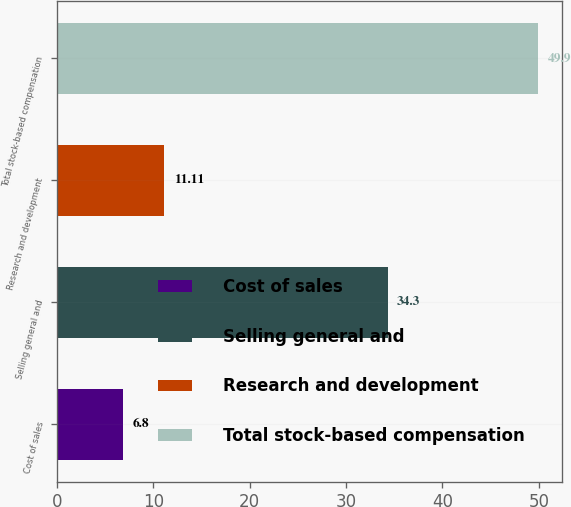<chart> <loc_0><loc_0><loc_500><loc_500><bar_chart><fcel>Cost of sales<fcel>Selling general and<fcel>Research and development<fcel>Total stock-based compensation<nl><fcel>6.8<fcel>34.3<fcel>11.11<fcel>49.9<nl></chart> 